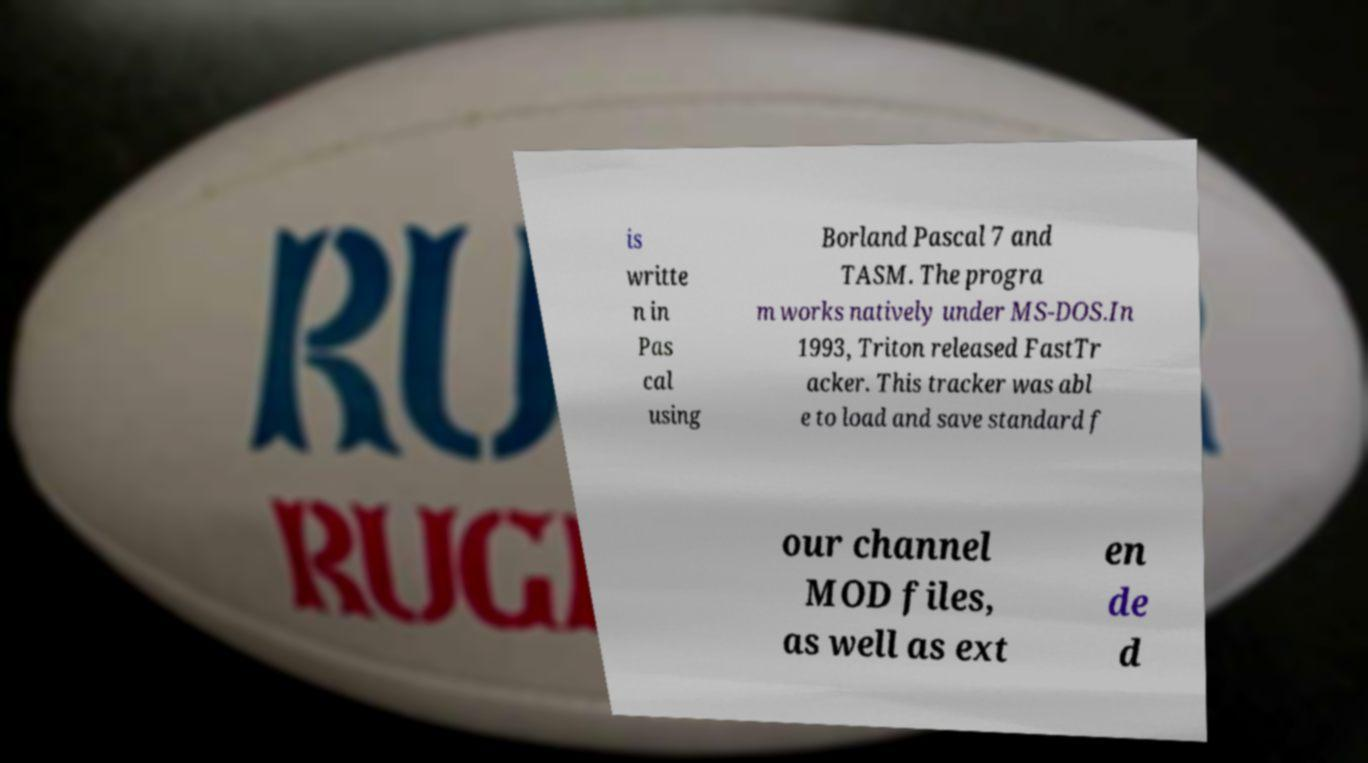For documentation purposes, I need the text within this image transcribed. Could you provide that? is writte n in Pas cal using Borland Pascal 7 and TASM. The progra m works natively under MS-DOS.In 1993, Triton released FastTr acker. This tracker was abl e to load and save standard f our channel MOD files, as well as ext en de d 